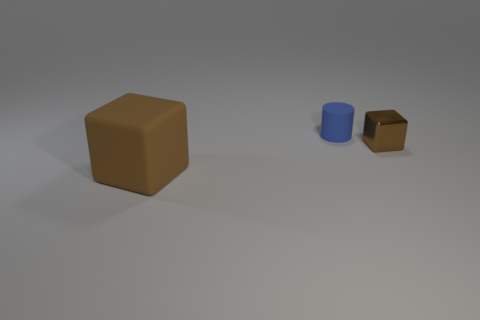Are there any other things that have the same size as the brown rubber block?
Provide a short and direct response. No. Are there any other things that have the same material as the tiny brown cube?
Provide a short and direct response. No. There is a brown object that is right of the brown thing that is in front of the tiny object in front of the blue matte cylinder; what shape is it?
Give a very brief answer. Cube. Does the small matte cylinder behind the large brown rubber block have the same color as the cube on the left side of the tiny brown block?
Make the answer very short. No. What number of metallic objects are either small blue cylinders or large brown cubes?
Your answer should be very brief. 0. The rubber object behind the block left of the block that is to the right of the large rubber thing is what color?
Keep it short and to the point. Blue. There is a large object that is the same shape as the small metal thing; what is its color?
Ensure brevity in your answer.  Brown. Is there any other thing that is the same color as the cylinder?
Ensure brevity in your answer.  No. How many other objects are the same material as the small cube?
Offer a very short reply. 0. What is the size of the shiny cube?
Offer a terse response. Small. 